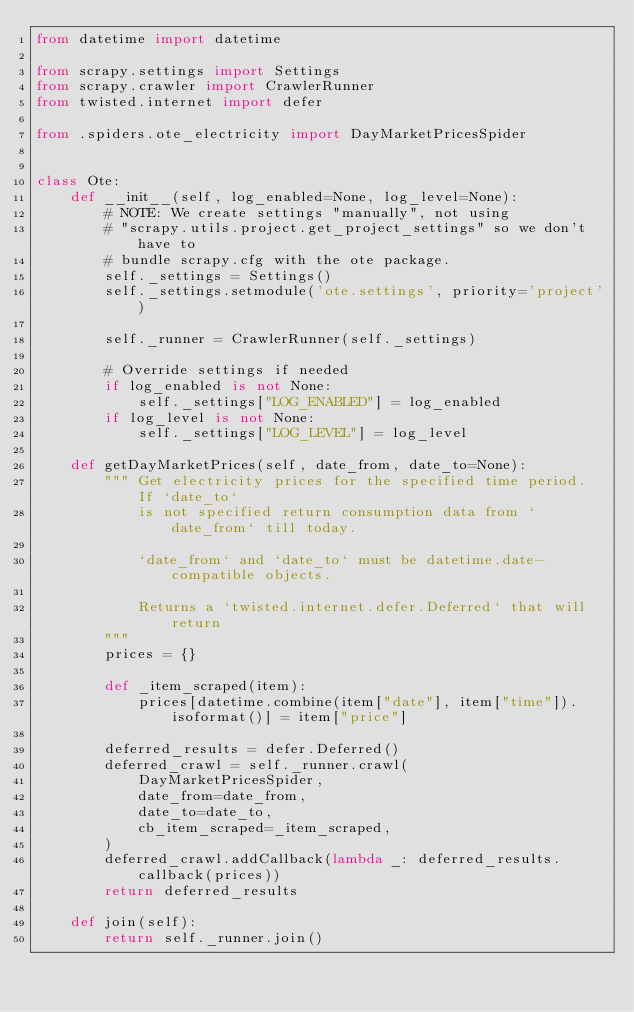Convert code to text. <code><loc_0><loc_0><loc_500><loc_500><_Python_>from datetime import datetime

from scrapy.settings import Settings
from scrapy.crawler import CrawlerRunner
from twisted.internet import defer

from .spiders.ote_electricity import DayMarketPricesSpider


class Ote:
    def __init__(self, log_enabled=None, log_level=None):
        # NOTE: We create settings "manually", not using
        # "scrapy.utils.project.get_project_settings" so we don't have to
        # bundle scrapy.cfg with the ote package.
        self._settings = Settings()
        self._settings.setmodule('ote.settings', priority='project')

        self._runner = CrawlerRunner(self._settings)

        # Override settings if needed
        if log_enabled is not None:
            self._settings["LOG_ENABLED"] = log_enabled
        if log_level is not None:
            self._settings["LOG_LEVEL"] = log_level

    def getDayMarketPrices(self, date_from, date_to=None):
        """ Get electricity prices for the specified time period.  If `date_to`
            is not specified return consumption data from `date_from` till today.

            `date_from` and `date_to` must be datetime.date-compatible objects.

            Returns a `twisted.internet.defer.Deferred` that will return
        """
        prices = {}

        def _item_scraped(item):
            prices[datetime.combine(item["date"], item["time"]).isoformat()] = item["price"]

        deferred_results = defer.Deferred()
        deferred_crawl = self._runner.crawl(
            DayMarketPricesSpider,
            date_from=date_from,
            date_to=date_to,
            cb_item_scraped=_item_scraped,
        )
        deferred_crawl.addCallback(lambda _: deferred_results.callback(prices))
        return deferred_results

    def join(self):
        return self._runner.join()
</code> 